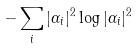<formula> <loc_0><loc_0><loc_500><loc_500>- \sum _ { i } | \alpha _ { i } | ^ { 2 } \log | \alpha _ { i } | ^ { 2 }</formula> 